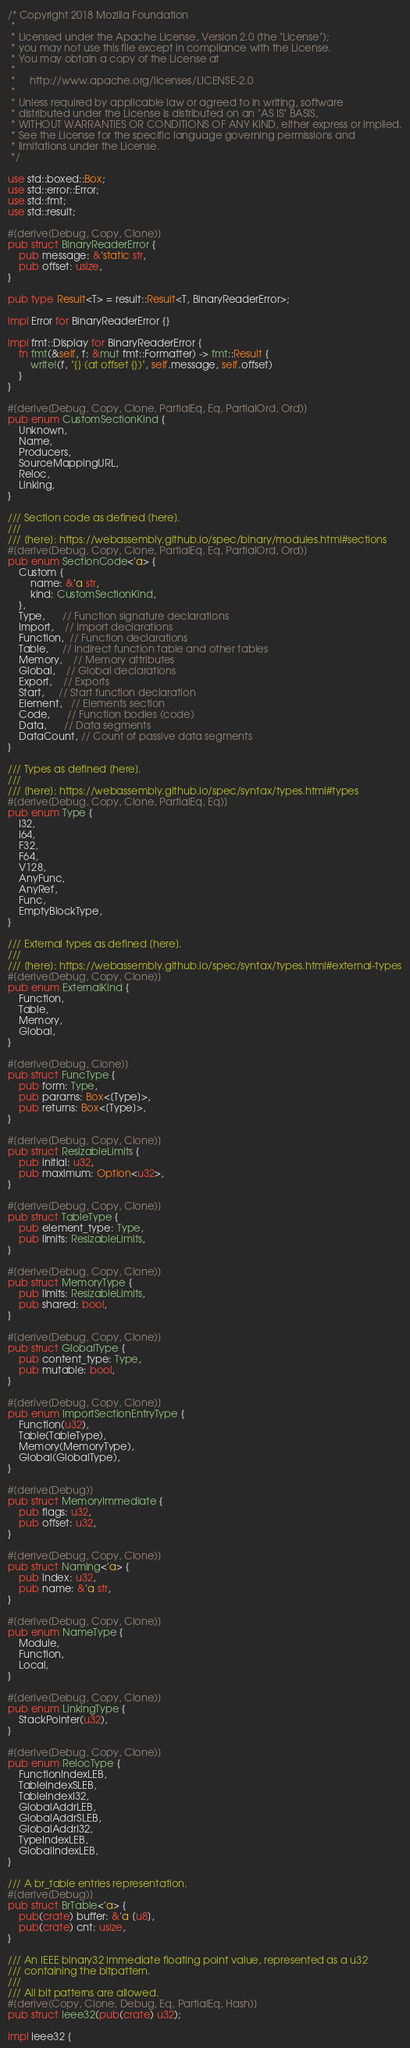Convert code to text. <code><loc_0><loc_0><loc_500><loc_500><_Rust_>/* Copyright 2018 Mozilla Foundation
 *
 * Licensed under the Apache License, Version 2.0 (the "License");
 * you may not use this file except in compliance with the License.
 * You may obtain a copy of the License at
 *
 *     http://www.apache.org/licenses/LICENSE-2.0
 *
 * Unless required by applicable law or agreed to in writing, software
 * distributed under the License is distributed on an "AS IS" BASIS,
 * WITHOUT WARRANTIES OR CONDITIONS OF ANY KIND, either express or implied.
 * See the License for the specific language governing permissions and
 * limitations under the License.
 */

use std::boxed::Box;
use std::error::Error;
use std::fmt;
use std::result;

#[derive(Debug, Copy, Clone)]
pub struct BinaryReaderError {
    pub message: &'static str,
    pub offset: usize,
}

pub type Result<T> = result::Result<T, BinaryReaderError>;

impl Error for BinaryReaderError {}

impl fmt::Display for BinaryReaderError {
    fn fmt(&self, f: &mut fmt::Formatter) -> fmt::Result {
        write!(f, "{} (at offset {})", self.message, self.offset)
    }
}

#[derive(Debug, Copy, Clone, PartialEq, Eq, PartialOrd, Ord)]
pub enum CustomSectionKind {
    Unknown,
    Name,
    Producers,
    SourceMappingURL,
    Reloc,
    Linking,
}

/// Section code as defined [here].
///
/// [here]: https://webassembly.github.io/spec/binary/modules.html#sections
#[derive(Debug, Copy, Clone, PartialEq, Eq, PartialOrd, Ord)]
pub enum SectionCode<'a> {
    Custom {
        name: &'a str,
        kind: CustomSectionKind,
    },
    Type,      // Function signature declarations
    Import,    // Import declarations
    Function,  // Function declarations
    Table,     // Indirect function table and other tables
    Memory,    // Memory attributes
    Global,    // Global declarations
    Export,    // Exports
    Start,     // Start function declaration
    Element,   // Elements section
    Code,      // Function bodies (code)
    Data,      // Data segments
    DataCount, // Count of passive data segments
}

/// Types as defined [here].
///
/// [here]: https://webassembly.github.io/spec/syntax/types.html#types
#[derive(Debug, Copy, Clone, PartialEq, Eq)]
pub enum Type {
    I32,
    I64,
    F32,
    F64,
    V128,
    AnyFunc,
    AnyRef,
    Func,
    EmptyBlockType,
}

/// External types as defined [here].
///
/// [here]: https://webassembly.github.io/spec/syntax/types.html#external-types
#[derive(Debug, Copy, Clone)]
pub enum ExternalKind {
    Function,
    Table,
    Memory,
    Global,
}

#[derive(Debug, Clone)]
pub struct FuncType {
    pub form: Type,
    pub params: Box<[Type]>,
    pub returns: Box<[Type]>,
}

#[derive(Debug, Copy, Clone)]
pub struct ResizableLimits {
    pub initial: u32,
    pub maximum: Option<u32>,
}

#[derive(Debug, Copy, Clone)]
pub struct TableType {
    pub element_type: Type,
    pub limits: ResizableLimits,
}

#[derive(Debug, Copy, Clone)]
pub struct MemoryType {
    pub limits: ResizableLimits,
    pub shared: bool,
}

#[derive(Debug, Copy, Clone)]
pub struct GlobalType {
    pub content_type: Type,
    pub mutable: bool,
}

#[derive(Debug, Copy, Clone)]
pub enum ImportSectionEntryType {
    Function(u32),
    Table(TableType),
    Memory(MemoryType),
    Global(GlobalType),
}

#[derive(Debug)]
pub struct MemoryImmediate {
    pub flags: u32,
    pub offset: u32,
}

#[derive(Debug, Copy, Clone)]
pub struct Naming<'a> {
    pub index: u32,
    pub name: &'a str,
}

#[derive(Debug, Copy, Clone)]
pub enum NameType {
    Module,
    Function,
    Local,
}

#[derive(Debug, Copy, Clone)]
pub enum LinkingType {
    StackPointer(u32),
}

#[derive(Debug, Copy, Clone)]
pub enum RelocType {
    FunctionIndexLEB,
    TableIndexSLEB,
    TableIndexI32,
    GlobalAddrLEB,
    GlobalAddrSLEB,
    GlobalAddrI32,
    TypeIndexLEB,
    GlobalIndexLEB,
}

/// A br_table entries representation.
#[derive(Debug)]
pub struct BrTable<'a> {
    pub(crate) buffer: &'a [u8],
    pub(crate) cnt: usize,
}

/// An IEEE binary32 immediate floating point value, represented as a u32
/// containing the bitpattern.
///
/// All bit patterns are allowed.
#[derive(Copy, Clone, Debug, Eq, PartialEq, Hash)]
pub struct Ieee32(pub(crate) u32);

impl Ieee32 {</code> 